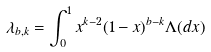Convert formula to latex. <formula><loc_0><loc_0><loc_500><loc_500>\lambda _ { b , k } = \int _ { 0 } ^ { 1 } x ^ { k - 2 } ( 1 - x ) ^ { b - k } \Lambda ( d x )</formula> 